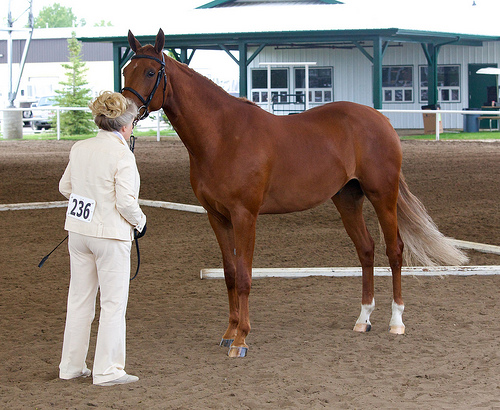<image>
Can you confirm if the number sign is on the jacket? Yes. Looking at the image, I can see the number sign is positioned on top of the jacket, with the jacket providing support. 